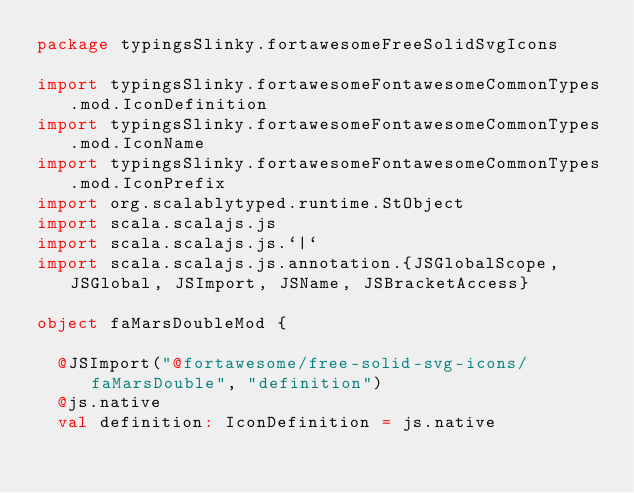<code> <loc_0><loc_0><loc_500><loc_500><_Scala_>package typingsSlinky.fortawesomeFreeSolidSvgIcons

import typingsSlinky.fortawesomeFontawesomeCommonTypes.mod.IconDefinition
import typingsSlinky.fortawesomeFontawesomeCommonTypes.mod.IconName
import typingsSlinky.fortawesomeFontawesomeCommonTypes.mod.IconPrefix
import org.scalablytyped.runtime.StObject
import scala.scalajs.js
import scala.scalajs.js.`|`
import scala.scalajs.js.annotation.{JSGlobalScope, JSGlobal, JSImport, JSName, JSBracketAccess}

object faMarsDoubleMod {
  
  @JSImport("@fortawesome/free-solid-svg-icons/faMarsDouble", "definition")
  @js.native
  val definition: IconDefinition = js.native
  </code> 